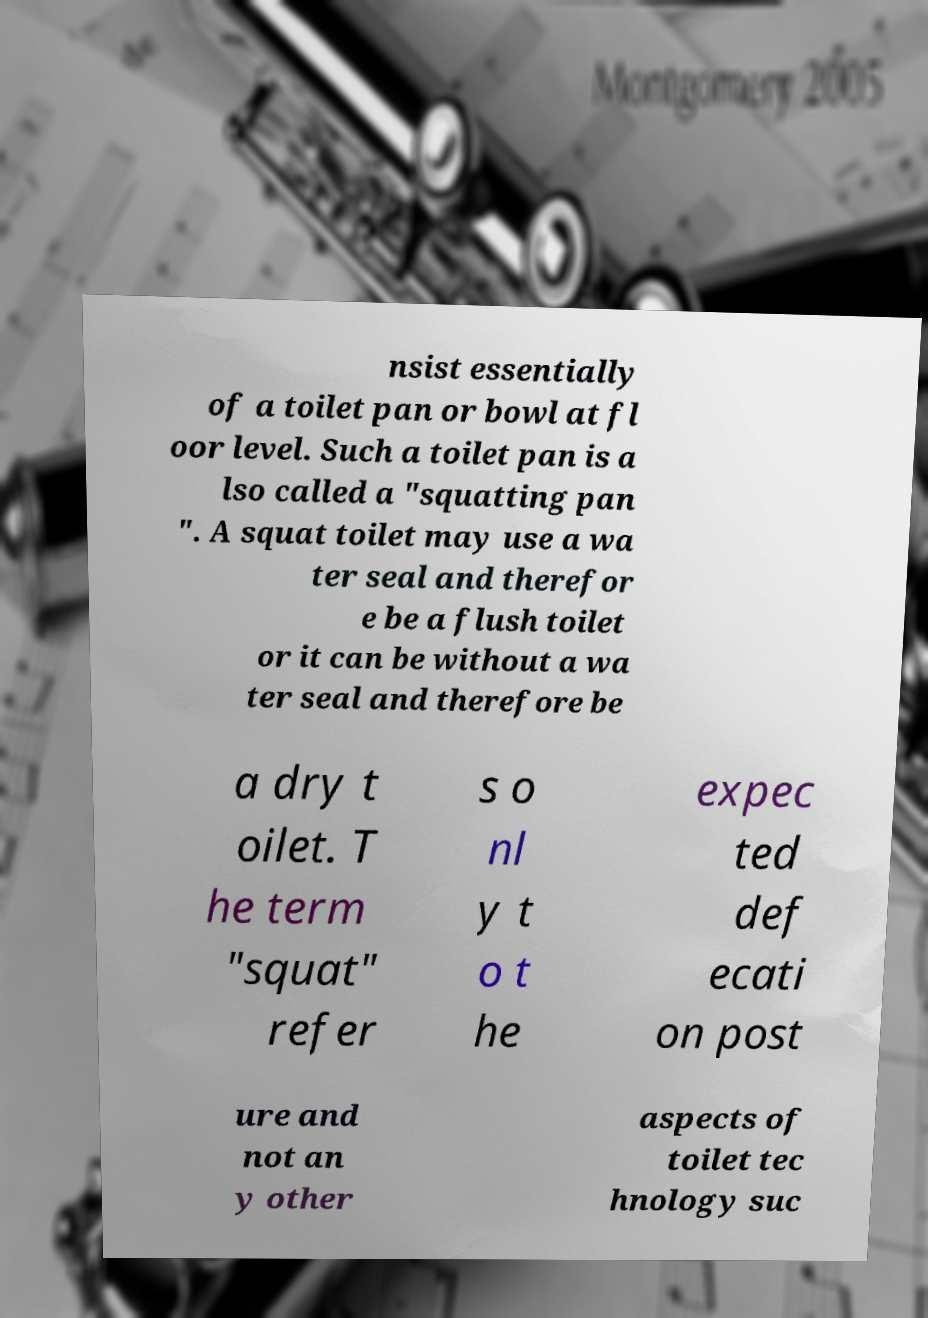I need the written content from this picture converted into text. Can you do that? nsist essentially of a toilet pan or bowl at fl oor level. Such a toilet pan is a lso called a "squatting pan ". A squat toilet may use a wa ter seal and therefor e be a flush toilet or it can be without a wa ter seal and therefore be a dry t oilet. T he term "squat" refer s o nl y t o t he expec ted def ecati on post ure and not an y other aspects of toilet tec hnology suc 